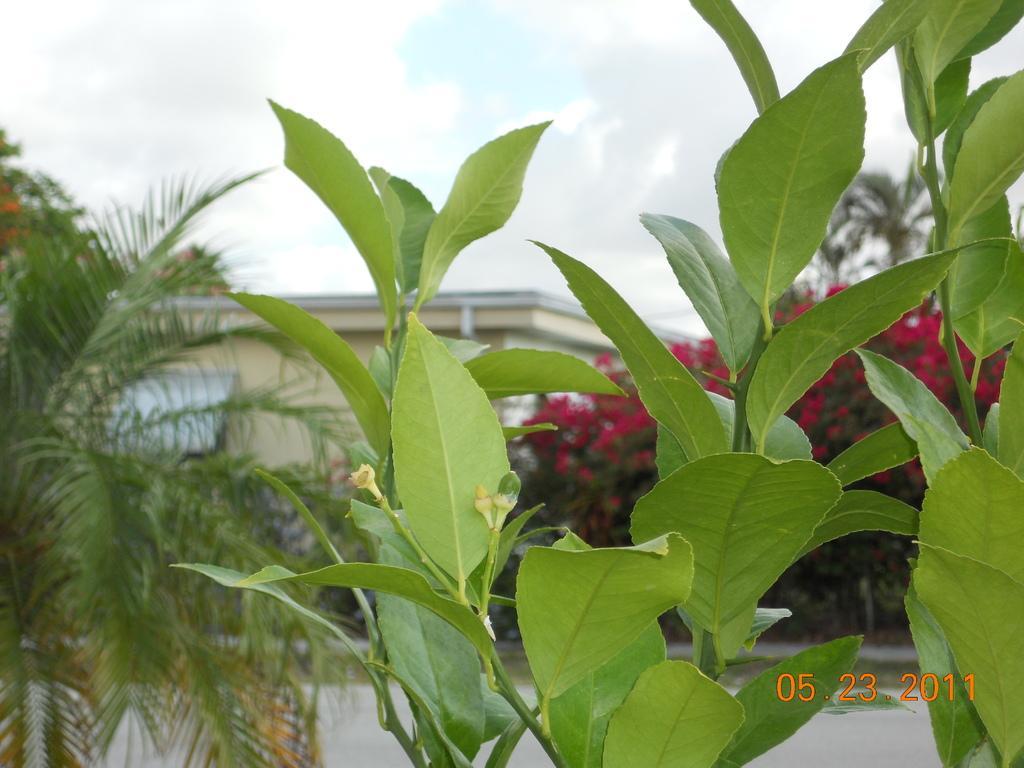Could you give a brief overview of what you see in this image? In this image, we can see a building and there are trees. At the top, there is sky and at the bottom, we can see some text. 